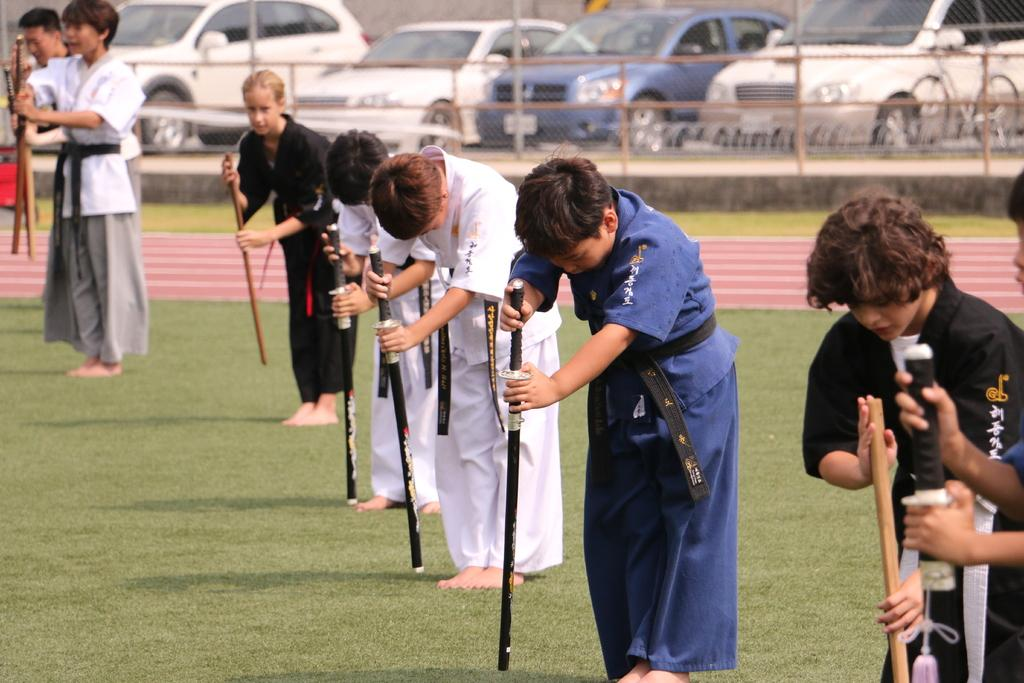What are the persons in the image doing? The persons in the image are standing on the ground and holding sticks in their hands. What can be seen in the background of the image? In the background of the image, there is a fence, grass, vehicles, and a bicycle. What might the persons be using the sticks for? It is unclear from the image what the persons might be using the sticks for. What type of shoe is hanging from the fence in the image? There is no shoe hanging from the fence in the image. How many corks are visible on the shelf in the image? There is no shelf or corks present in the image. 